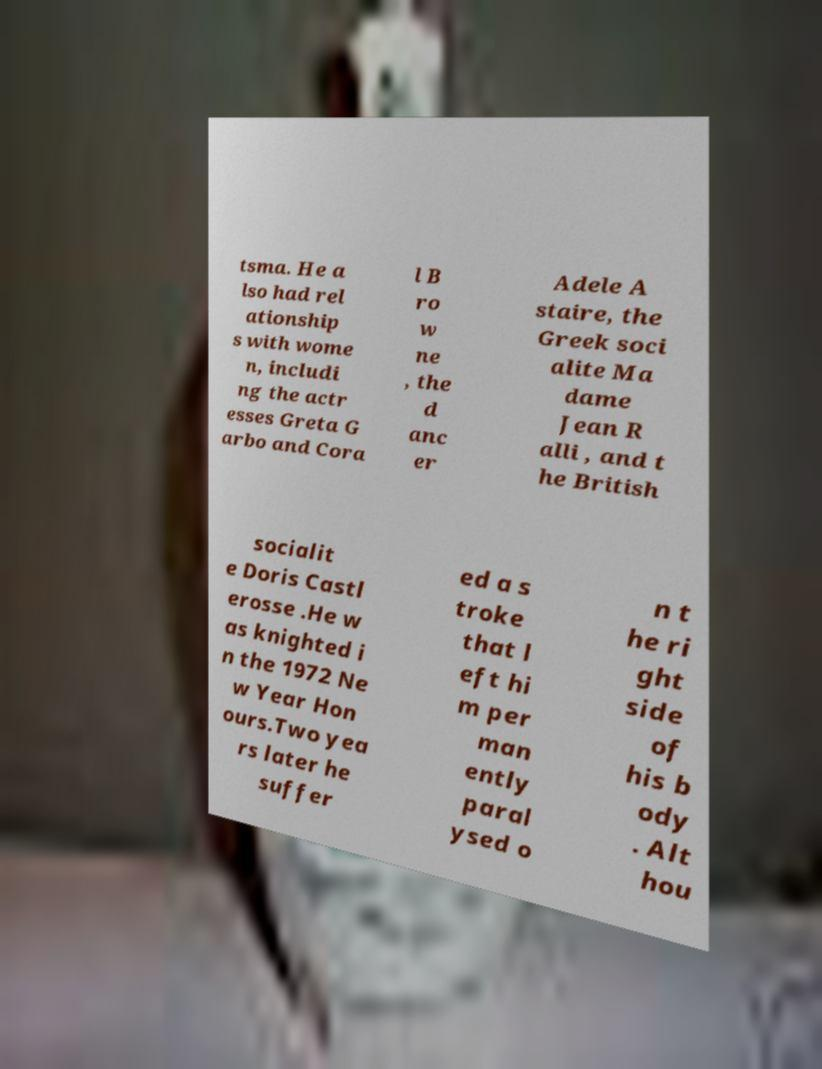Can you read and provide the text displayed in the image?This photo seems to have some interesting text. Can you extract and type it out for me? tsma. He a lso had rel ationship s with wome n, includi ng the actr esses Greta G arbo and Cora l B ro w ne , the d anc er Adele A staire, the Greek soci alite Ma dame Jean R alli , and t he British socialit e Doris Castl erosse .He w as knighted i n the 1972 Ne w Year Hon ours.Two yea rs later he suffer ed a s troke that l eft hi m per man ently paral ysed o n t he ri ght side of his b ody . Alt hou 